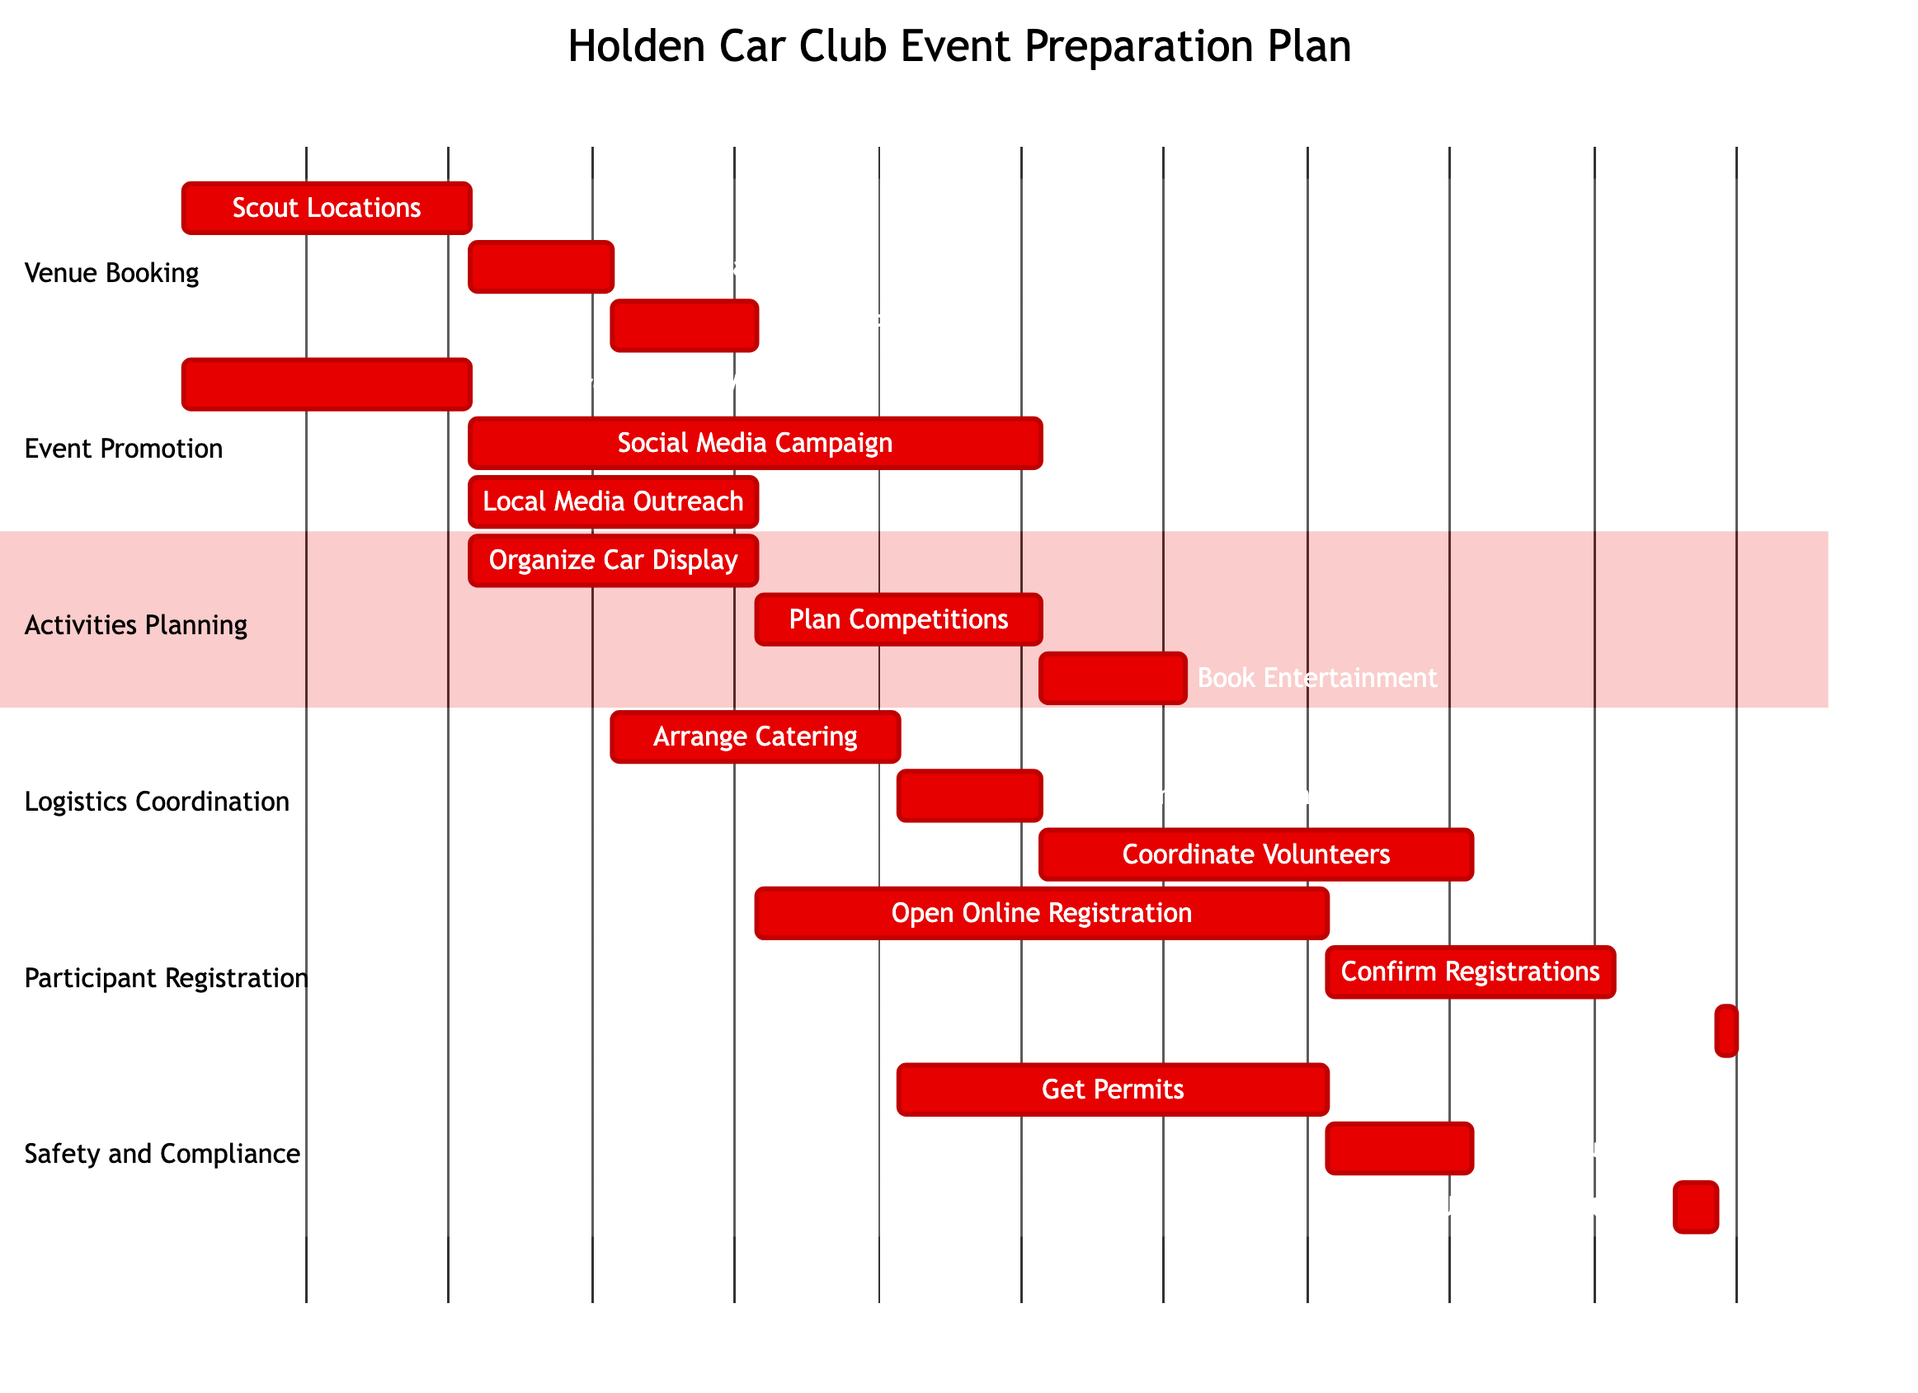What's the duration of "Scout Locations"? The task "Scout Locations" has a specified duration of "2 weeks" in the Gantt chart.
Answer: 2 weeks What task follows "Secure Main Venue"? "Arrange Parking" directly follows "Secure Main Venue," as indicated by the sequential flow in the Gantt chart.
Answer: Arrange Parking How many subtasks are in the "Event Promotion" section? There are three subtasks under "Event Promotion": "Design Promotional Materials," "Social Media Campaign," and "Local Media Outreach." Thus, the total count is three.
Answer: 3 What is the total duration for "Participant Registration"? "Open Online Registration" takes 4 weeks, followed by "Confirm Registrations" with 2 weeks, and "On-site Check-in" is 1 day. In total, it combines to 4 weeks and 2 weeks, equating to 6 weeks.
Answer: 6 weeks Which task in the "Safety and Compliance" section takes the longest? "Get Permits" takes 3 weeks, which is the longest duration for any task in the "Safety and Compliance" section, thus making it the longest.
Answer: Get Permits How many tasks must be completed before "Organize Car Display"? The task "Organize Car Display" begins after "Design Promotional Materials" (which takes 2 weeks); thus, no tasks directly precede it. However, "Design Promotional Materials" must start and complete for it to begin.
Answer: 1 Which task overlaps with "Social Media Campaign"? "Local Media Outreach" overlaps with "Social Media Campaign" as it starts after "Design Promotional Materials," but both occur concurrently while also involving promotional efforts.
Answer: Local Media Outreach What is the start date for "On-site Check-in"? The task "On-site Check-in" is scheduled to begin on "2023-07-15" as indicated by the timeline within the Gantt chart.
Answer: 2023-07-15 How long is the "Rent Event Equipment" task? "Rent Event Equipment" is scheduled for a duration of "1 week" according to the Gantt chart details.
Answer: 1 week 